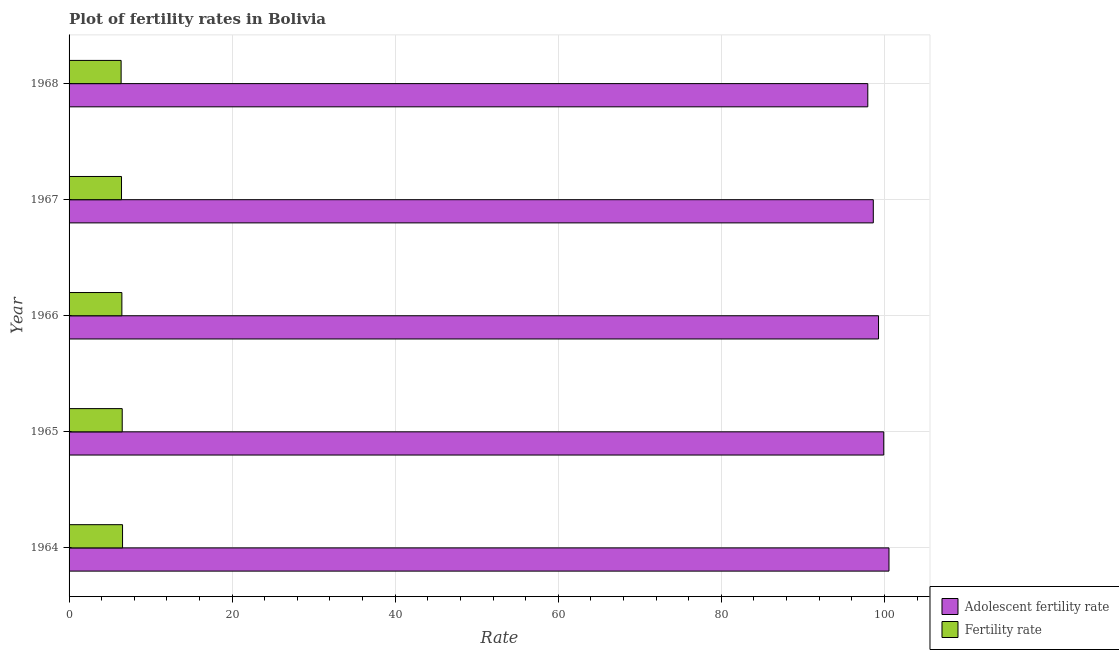How many different coloured bars are there?
Offer a very short reply. 2. How many bars are there on the 1st tick from the top?
Your answer should be very brief. 2. What is the label of the 1st group of bars from the top?
Offer a very short reply. 1968. In how many cases, is the number of bars for a given year not equal to the number of legend labels?
Your answer should be very brief. 0. What is the fertility rate in 1964?
Provide a short and direct response. 6.56. Across all years, what is the maximum fertility rate?
Your answer should be compact. 6.56. Across all years, what is the minimum adolescent fertility rate?
Keep it short and to the point. 97.96. In which year was the adolescent fertility rate maximum?
Give a very brief answer. 1964. In which year was the adolescent fertility rate minimum?
Ensure brevity in your answer.  1968. What is the total fertility rate in the graph?
Provide a succinct answer. 32.37. What is the difference between the fertility rate in 1966 and that in 1968?
Your response must be concise. 0.09. What is the difference between the adolescent fertility rate in 1967 and the fertility rate in 1968?
Make the answer very short. 92.25. What is the average adolescent fertility rate per year?
Provide a succinct answer. 99.27. In the year 1965, what is the difference between the fertility rate and adolescent fertility rate?
Your answer should be compact. -93.4. In how many years, is the adolescent fertility rate greater than 48 ?
Ensure brevity in your answer.  5. What is the ratio of the fertility rate in 1964 to that in 1967?
Your answer should be very brief. 1.02. Is the fertility rate in 1966 less than that in 1968?
Offer a terse response. No. Is the difference between the fertility rate in 1966 and 1967 greater than the difference between the adolescent fertility rate in 1966 and 1967?
Your answer should be compact. No. What is the difference between the highest and the second highest fertility rate?
Keep it short and to the point. 0.04. What is the difference between the highest and the lowest adolescent fertility rate?
Make the answer very short. 2.6. In how many years, is the fertility rate greater than the average fertility rate taken over all years?
Give a very brief answer. 3. What does the 2nd bar from the top in 1965 represents?
Offer a terse response. Adolescent fertility rate. What does the 1st bar from the bottom in 1964 represents?
Your answer should be compact. Adolescent fertility rate. How many bars are there?
Give a very brief answer. 10. Are all the bars in the graph horizontal?
Keep it short and to the point. Yes. How many years are there in the graph?
Ensure brevity in your answer.  5. Are the values on the major ticks of X-axis written in scientific E-notation?
Keep it short and to the point. No. Does the graph contain grids?
Give a very brief answer. Yes. How are the legend labels stacked?
Keep it short and to the point. Vertical. What is the title of the graph?
Offer a terse response. Plot of fertility rates in Bolivia. What is the label or title of the X-axis?
Offer a terse response. Rate. What is the label or title of the Y-axis?
Ensure brevity in your answer.  Year. What is the Rate in Adolescent fertility rate in 1964?
Your answer should be very brief. 100.56. What is the Rate in Fertility rate in 1964?
Your answer should be very brief. 6.56. What is the Rate of Adolescent fertility rate in 1965?
Keep it short and to the point. 99.92. What is the Rate in Fertility rate in 1965?
Your answer should be compact. 6.52. What is the Rate in Adolescent fertility rate in 1966?
Keep it short and to the point. 99.28. What is the Rate of Fertility rate in 1966?
Provide a short and direct response. 6.48. What is the Rate of Adolescent fertility rate in 1967?
Keep it short and to the point. 98.64. What is the Rate of Fertility rate in 1967?
Your response must be concise. 6.43. What is the Rate in Adolescent fertility rate in 1968?
Provide a short and direct response. 97.96. What is the Rate of Fertility rate in 1968?
Your answer should be very brief. 6.38. Across all years, what is the maximum Rate of Adolescent fertility rate?
Offer a very short reply. 100.56. Across all years, what is the maximum Rate of Fertility rate?
Make the answer very short. 6.56. Across all years, what is the minimum Rate of Adolescent fertility rate?
Give a very brief answer. 97.96. Across all years, what is the minimum Rate in Fertility rate?
Your answer should be very brief. 6.38. What is the total Rate of Adolescent fertility rate in the graph?
Your response must be concise. 496.35. What is the total Rate in Fertility rate in the graph?
Your answer should be compact. 32.37. What is the difference between the Rate in Adolescent fertility rate in 1964 and that in 1965?
Provide a short and direct response. 0.64. What is the difference between the Rate in Adolescent fertility rate in 1964 and that in 1966?
Your answer should be compact. 1.28. What is the difference between the Rate of Fertility rate in 1964 and that in 1966?
Provide a succinct answer. 0.08. What is the difference between the Rate in Adolescent fertility rate in 1964 and that in 1967?
Ensure brevity in your answer.  1.92. What is the difference between the Rate of Fertility rate in 1964 and that in 1967?
Provide a succinct answer. 0.13. What is the difference between the Rate of Adolescent fertility rate in 1964 and that in 1968?
Offer a terse response. 2.6. What is the difference between the Rate in Fertility rate in 1964 and that in 1968?
Ensure brevity in your answer.  0.17. What is the difference between the Rate of Adolescent fertility rate in 1965 and that in 1966?
Provide a succinct answer. 0.64. What is the difference between the Rate of Fertility rate in 1965 and that in 1966?
Offer a very short reply. 0.04. What is the difference between the Rate of Adolescent fertility rate in 1965 and that in 1967?
Your response must be concise. 1.28. What is the difference between the Rate in Fertility rate in 1965 and that in 1967?
Offer a very short reply. 0.09. What is the difference between the Rate of Adolescent fertility rate in 1965 and that in 1968?
Your answer should be compact. 1.96. What is the difference between the Rate of Fertility rate in 1965 and that in 1968?
Your response must be concise. 0.14. What is the difference between the Rate of Adolescent fertility rate in 1966 and that in 1967?
Ensure brevity in your answer.  0.64. What is the difference between the Rate in Fertility rate in 1966 and that in 1967?
Give a very brief answer. 0.04. What is the difference between the Rate in Adolescent fertility rate in 1966 and that in 1968?
Give a very brief answer. 1.32. What is the difference between the Rate of Fertility rate in 1966 and that in 1968?
Your answer should be very brief. 0.09. What is the difference between the Rate in Adolescent fertility rate in 1967 and that in 1968?
Give a very brief answer. 0.67. What is the difference between the Rate in Fertility rate in 1967 and that in 1968?
Your response must be concise. 0.05. What is the difference between the Rate of Adolescent fertility rate in 1964 and the Rate of Fertility rate in 1965?
Your answer should be very brief. 94.04. What is the difference between the Rate in Adolescent fertility rate in 1964 and the Rate in Fertility rate in 1966?
Offer a very short reply. 94.08. What is the difference between the Rate in Adolescent fertility rate in 1964 and the Rate in Fertility rate in 1967?
Your response must be concise. 94.13. What is the difference between the Rate in Adolescent fertility rate in 1964 and the Rate in Fertility rate in 1968?
Provide a short and direct response. 94.17. What is the difference between the Rate of Adolescent fertility rate in 1965 and the Rate of Fertility rate in 1966?
Keep it short and to the point. 93.44. What is the difference between the Rate of Adolescent fertility rate in 1965 and the Rate of Fertility rate in 1967?
Your answer should be compact. 93.49. What is the difference between the Rate in Adolescent fertility rate in 1965 and the Rate in Fertility rate in 1968?
Your response must be concise. 93.53. What is the difference between the Rate of Adolescent fertility rate in 1966 and the Rate of Fertility rate in 1967?
Ensure brevity in your answer.  92.84. What is the difference between the Rate in Adolescent fertility rate in 1966 and the Rate in Fertility rate in 1968?
Your answer should be very brief. 92.89. What is the difference between the Rate of Adolescent fertility rate in 1967 and the Rate of Fertility rate in 1968?
Provide a short and direct response. 92.25. What is the average Rate of Adolescent fertility rate per year?
Give a very brief answer. 99.27. What is the average Rate in Fertility rate per year?
Give a very brief answer. 6.47. In the year 1964, what is the difference between the Rate in Adolescent fertility rate and Rate in Fertility rate?
Your response must be concise. 94. In the year 1965, what is the difference between the Rate of Adolescent fertility rate and Rate of Fertility rate?
Give a very brief answer. 93.4. In the year 1966, what is the difference between the Rate of Adolescent fertility rate and Rate of Fertility rate?
Offer a terse response. 92.8. In the year 1967, what is the difference between the Rate in Adolescent fertility rate and Rate in Fertility rate?
Keep it short and to the point. 92.2. In the year 1968, what is the difference between the Rate of Adolescent fertility rate and Rate of Fertility rate?
Make the answer very short. 91.58. What is the ratio of the Rate of Adolescent fertility rate in 1964 to that in 1965?
Give a very brief answer. 1.01. What is the ratio of the Rate in Fertility rate in 1964 to that in 1965?
Offer a terse response. 1.01. What is the ratio of the Rate of Adolescent fertility rate in 1964 to that in 1966?
Ensure brevity in your answer.  1.01. What is the ratio of the Rate of Fertility rate in 1964 to that in 1966?
Give a very brief answer. 1.01. What is the ratio of the Rate in Adolescent fertility rate in 1964 to that in 1967?
Offer a terse response. 1.02. What is the ratio of the Rate of Fertility rate in 1964 to that in 1967?
Provide a short and direct response. 1.02. What is the ratio of the Rate in Adolescent fertility rate in 1964 to that in 1968?
Your answer should be compact. 1.03. What is the ratio of the Rate of Fertility rate in 1964 to that in 1968?
Offer a terse response. 1.03. What is the ratio of the Rate in Adolescent fertility rate in 1965 to that in 1966?
Provide a succinct answer. 1.01. What is the ratio of the Rate of Fertility rate in 1965 to that in 1967?
Give a very brief answer. 1.01. What is the ratio of the Rate in Adolescent fertility rate in 1965 to that in 1968?
Make the answer very short. 1.02. What is the ratio of the Rate of Fertility rate in 1965 to that in 1968?
Your answer should be very brief. 1.02. What is the ratio of the Rate in Fertility rate in 1966 to that in 1967?
Provide a short and direct response. 1.01. What is the ratio of the Rate in Adolescent fertility rate in 1966 to that in 1968?
Keep it short and to the point. 1.01. What is the ratio of the Rate of Fertility rate in 1966 to that in 1968?
Keep it short and to the point. 1.01. What is the ratio of the Rate of Adolescent fertility rate in 1967 to that in 1968?
Offer a terse response. 1.01. What is the ratio of the Rate in Fertility rate in 1967 to that in 1968?
Ensure brevity in your answer.  1.01. What is the difference between the highest and the second highest Rate in Adolescent fertility rate?
Your response must be concise. 0.64. What is the difference between the highest and the second highest Rate of Fertility rate?
Provide a short and direct response. 0.04. What is the difference between the highest and the lowest Rate in Adolescent fertility rate?
Your answer should be compact. 2.6. What is the difference between the highest and the lowest Rate in Fertility rate?
Your answer should be compact. 0.17. 